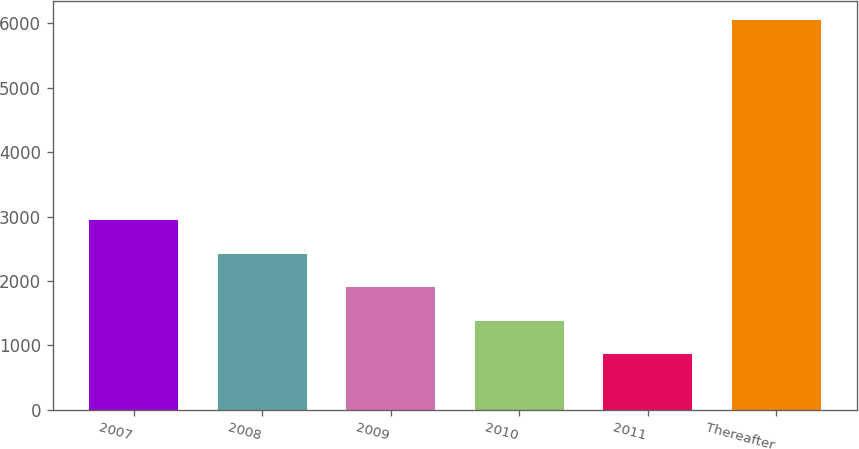<chart> <loc_0><loc_0><loc_500><loc_500><bar_chart><fcel>2007<fcel>2008<fcel>2009<fcel>2010<fcel>2011<fcel>Thereafter<nl><fcel>2940.6<fcel>2422.7<fcel>1904.8<fcel>1386.9<fcel>869<fcel>6048<nl></chart> 